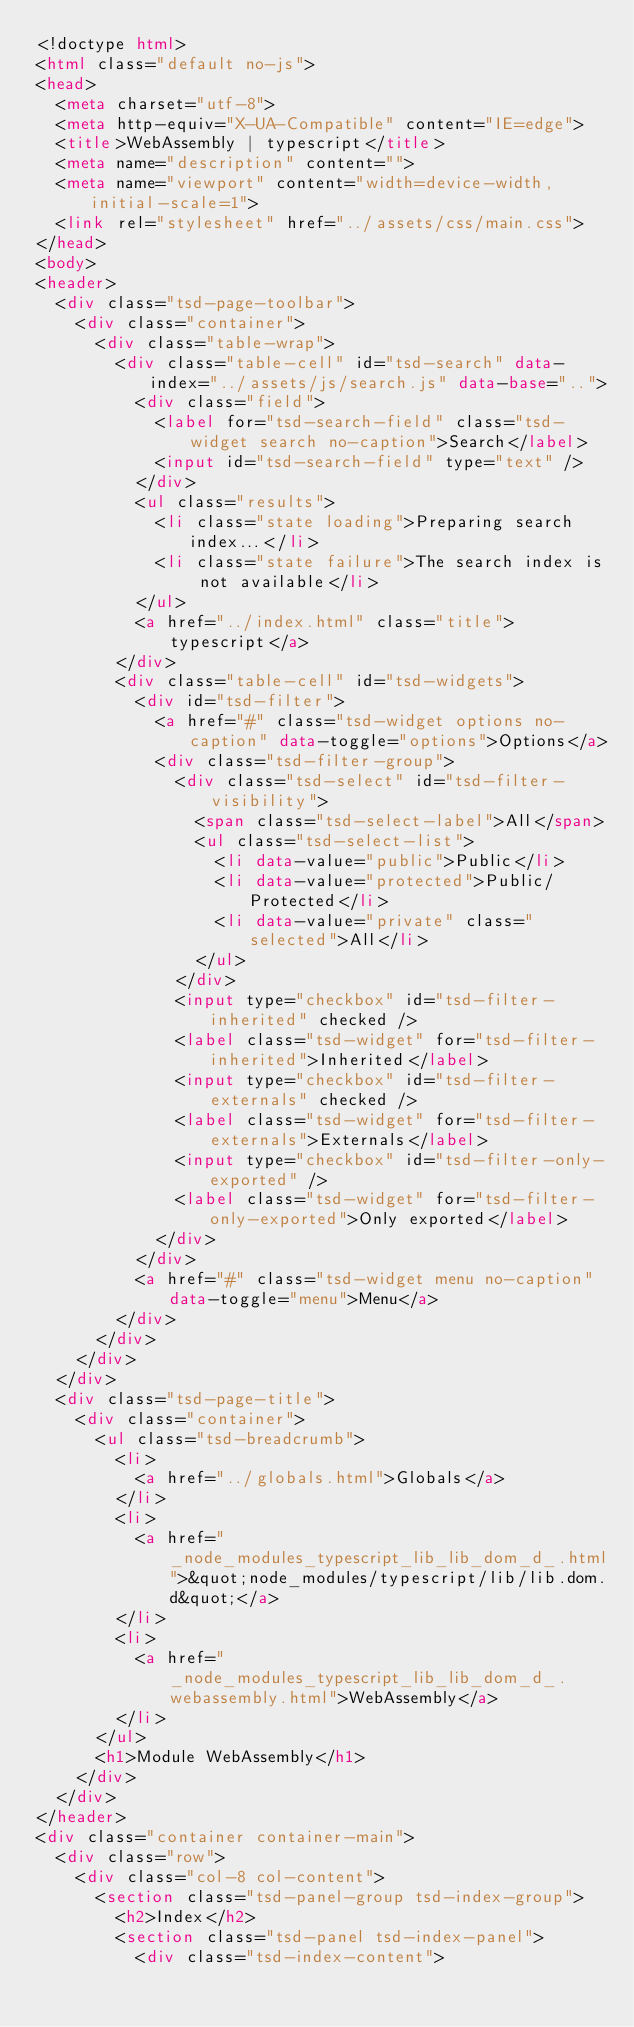<code> <loc_0><loc_0><loc_500><loc_500><_HTML_><!doctype html>
<html class="default no-js">
<head>
	<meta charset="utf-8">
	<meta http-equiv="X-UA-Compatible" content="IE=edge">
	<title>WebAssembly | typescript</title>
	<meta name="description" content="">
	<meta name="viewport" content="width=device-width, initial-scale=1">
	<link rel="stylesheet" href="../assets/css/main.css">
</head>
<body>
<header>
	<div class="tsd-page-toolbar">
		<div class="container">
			<div class="table-wrap">
				<div class="table-cell" id="tsd-search" data-index="../assets/js/search.js" data-base="..">
					<div class="field">
						<label for="tsd-search-field" class="tsd-widget search no-caption">Search</label>
						<input id="tsd-search-field" type="text" />
					</div>
					<ul class="results">
						<li class="state loading">Preparing search index...</li>
						<li class="state failure">The search index is not available</li>
					</ul>
					<a href="../index.html" class="title">typescript</a>
				</div>
				<div class="table-cell" id="tsd-widgets">
					<div id="tsd-filter">
						<a href="#" class="tsd-widget options no-caption" data-toggle="options">Options</a>
						<div class="tsd-filter-group">
							<div class="tsd-select" id="tsd-filter-visibility">
								<span class="tsd-select-label">All</span>
								<ul class="tsd-select-list">
									<li data-value="public">Public</li>
									<li data-value="protected">Public/Protected</li>
									<li data-value="private" class="selected">All</li>
								</ul>
							</div>
							<input type="checkbox" id="tsd-filter-inherited" checked />
							<label class="tsd-widget" for="tsd-filter-inherited">Inherited</label>
							<input type="checkbox" id="tsd-filter-externals" checked />
							<label class="tsd-widget" for="tsd-filter-externals">Externals</label>
							<input type="checkbox" id="tsd-filter-only-exported" />
							<label class="tsd-widget" for="tsd-filter-only-exported">Only exported</label>
						</div>
					</div>
					<a href="#" class="tsd-widget menu no-caption" data-toggle="menu">Menu</a>
				</div>
			</div>
		</div>
	</div>
	<div class="tsd-page-title">
		<div class="container">
			<ul class="tsd-breadcrumb">
				<li>
					<a href="../globals.html">Globals</a>
				</li>
				<li>
					<a href="_node_modules_typescript_lib_lib_dom_d_.html">&quot;node_modules/typescript/lib/lib.dom.d&quot;</a>
				</li>
				<li>
					<a href="_node_modules_typescript_lib_lib_dom_d_.webassembly.html">WebAssembly</a>
				</li>
			</ul>
			<h1>Module WebAssembly</h1>
		</div>
	</div>
</header>
<div class="container container-main">
	<div class="row">
		<div class="col-8 col-content">
			<section class="tsd-panel-group tsd-index-group">
				<h2>Index</h2>
				<section class="tsd-panel tsd-index-panel">
					<div class="tsd-index-content"></code> 